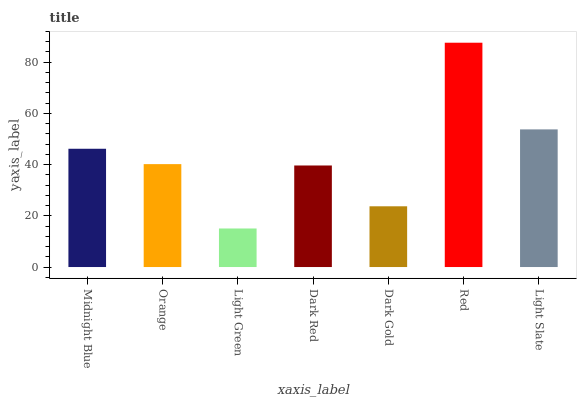Is Light Green the minimum?
Answer yes or no. Yes. Is Red the maximum?
Answer yes or no. Yes. Is Orange the minimum?
Answer yes or no. No. Is Orange the maximum?
Answer yes or no. No. Is Midnight Blue greater than Orange?
Answer yes or no. Yes. Is Orange less than Midnight Blue?
Answer yes or no. Yes. Is Orange greater than Midnight Blue?
Answer yes or no. No. Is Midnight Blue less than Orange?
Answer yes or no. No. Is Orange the high median?
Answer yes or no. Yes. Is Orange the low median?
Answer yes or no. Yes. Is Light Slate the high median?
Answer yes or no. No. Is Red the low median?
Answer yes or no. No. 